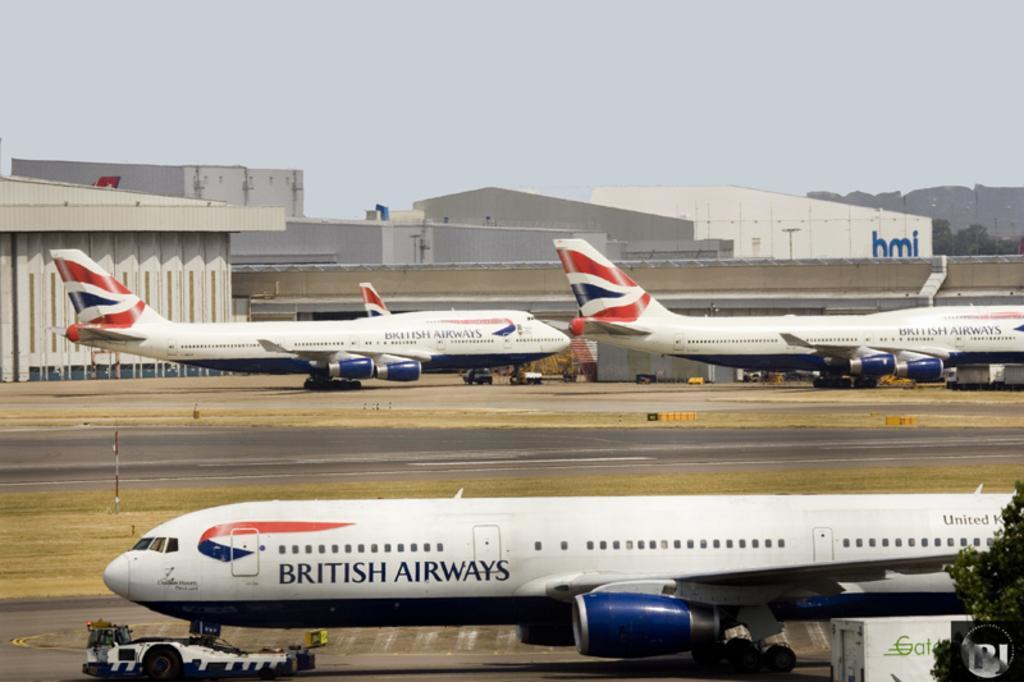Please provide a concise description of this image. In this image I can see aeroplanes. There are trees, buildings and in the background there is sky. 